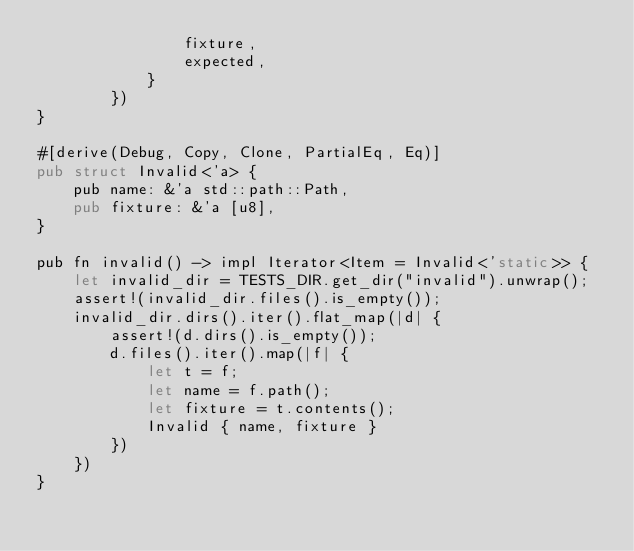<code> <loc_0><loc_0><loc_500><loc_500><_Rust_>                fixture,
                expected,
            }
        })
}

#[derive(Debug, Copy, Clone, PartialEq, Eq)]
pub struct Invalid<'a> {
    pub name: &'a std::path::Path,
    pub fixture: &'a [u8],
}

pub fn invalid() -> impl Iterator<Item = Invalid<'static>> {
    let invalid_dir = TESTS_DIR.get_dir("invalid").unwrap();
    assert!(invalid_dir.files().is_empty());
    invalid_dir.dirs().iter().flat_map(|d| {
        assert!(d.dirs().is_empty());
        d.files().iter().map(|f| {
            let t = f;
            let name = f.path();
            let fixture = t.contents();
            Invalid { name, fixture }
        })
    })
}
</code> 